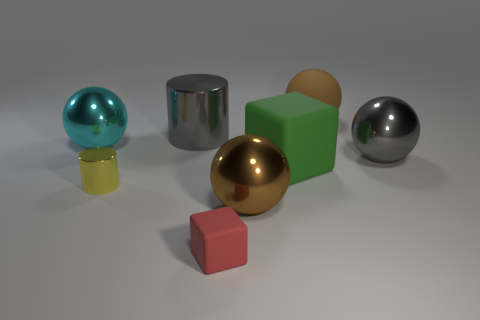There is a big object that is the same color as the large metallic cylinder; what is its material?
Your answer should be compact. Metal. What material is the brown sphere on the left side of the green matte thing?
Your answer should be very brief. Metal. Does the big gray thing that is to the right of the big cylinder have the same material as the yellow cylinder?
Provide a succinct answer. Yes. What number of things are small matte things or objects that are on the right side of the gray cylinder?
Make the answer very short. 5. The other object that is the same shape as the small matte thing is what size?
Give a very brief answer. Large. There is a cyan object; are there any metallic balls on the right side of it?
Make the answer very short. Yes. There is a rubber thing that is behind the large matte block; does it have the same color as the ball that is in front of the yellow thing?
Give a very brief answer. Yes. Are there any red rubber things that have the same shape as the green object?
Your response must be concise. Yes. What number of other things are there of the same color as the large cylinder?
Ensure brevity in your answer.  1. The cube on the right side of the rubber thing that is in front of the brown sphere that is in front of the tiny yellow cylinder is what color?
Your answer should be compact. Green. 